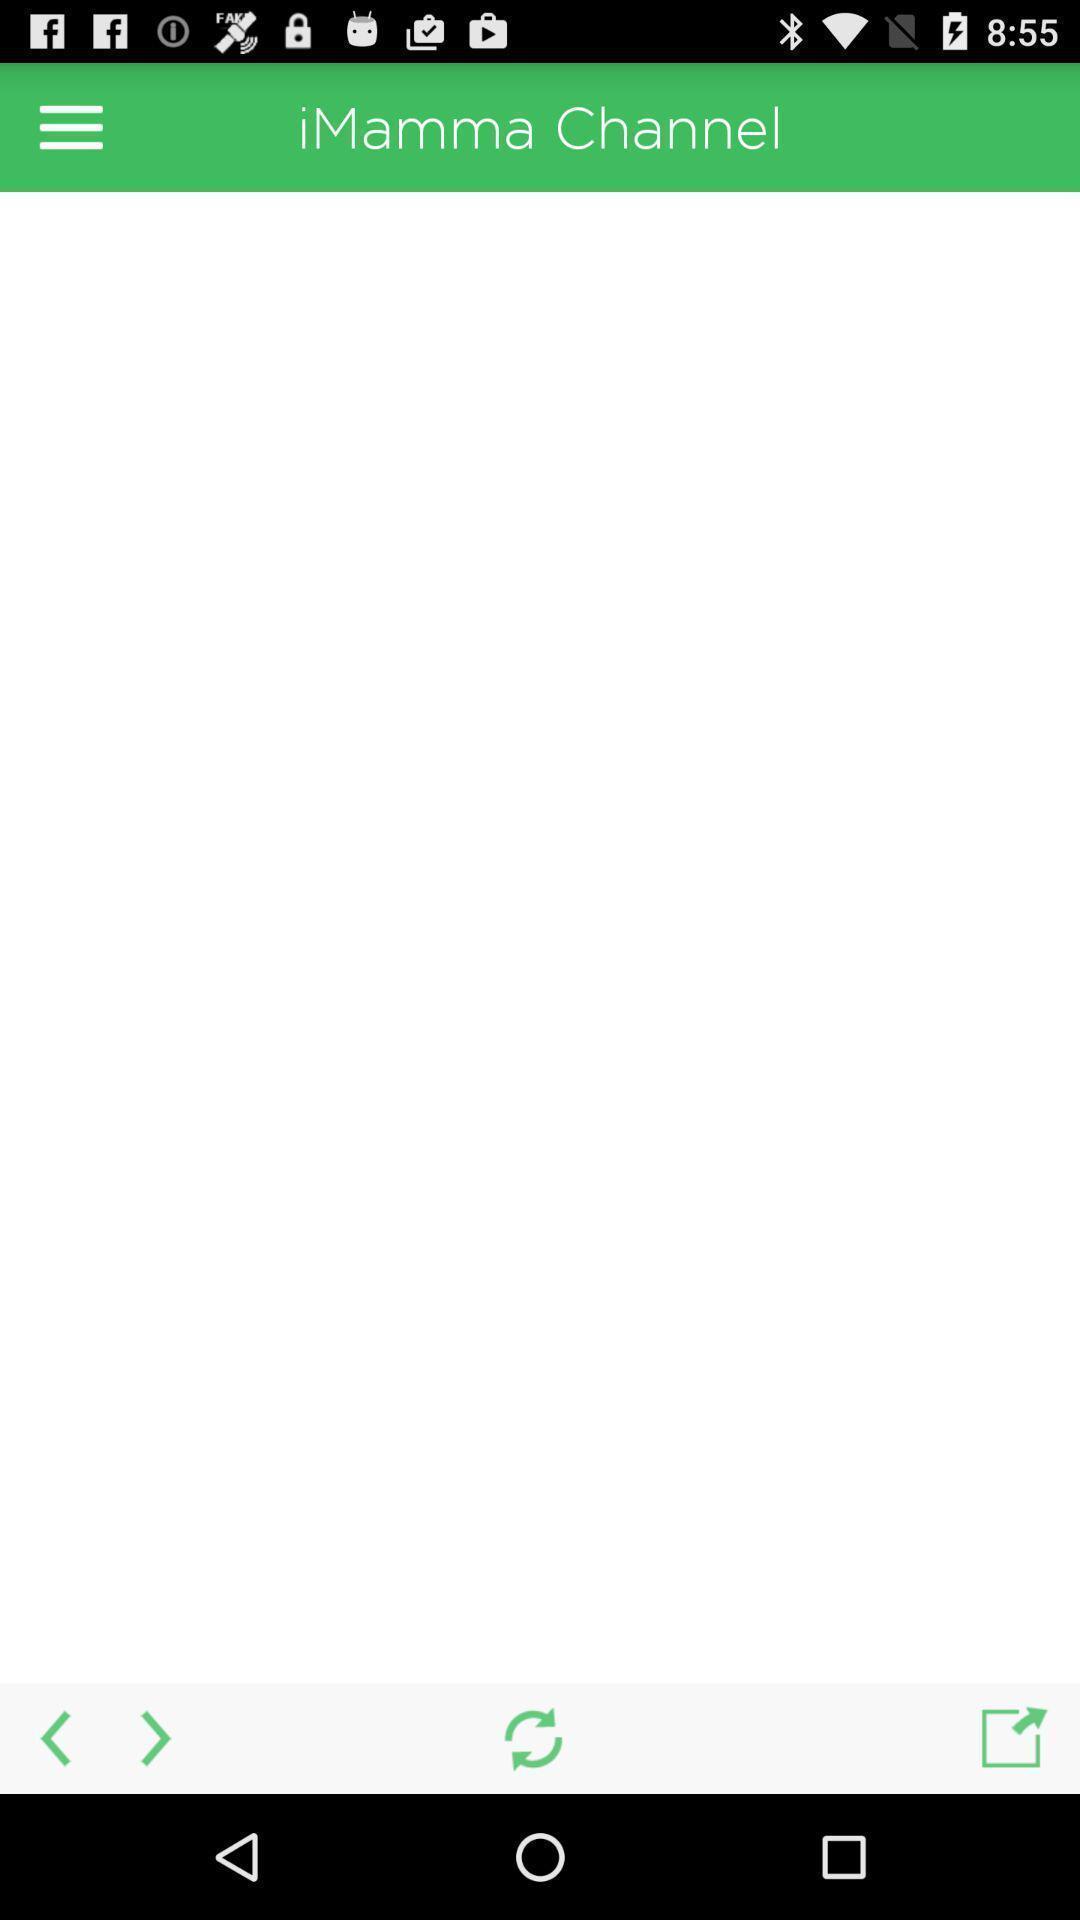Give me a narrative description of this picture. Page displaying different icons. 